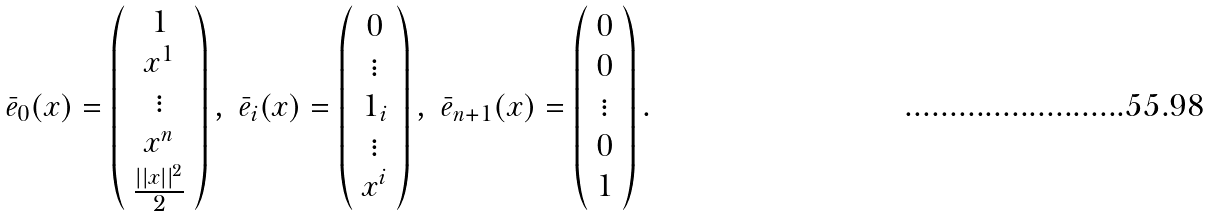<formula> <loc_0><loc_0><loc_500><loc_500>\bar { e } _ { 0 } ( x ) = \left ( \begin{array} { c } 1 \\ x ^ { 1 } \\ \vdots \\ x ^ { n } \\ \frac { | | x | | ^ { 2 } } { 2 } \end{array} \right ) , \ \bar { e } _ { i } ( x ) = \left ( \begin{array} { c } 0 \\ \vdots \\ 1 _ { i } \\ \vdots \\ x ^ { i } \end{array} \right ) , \ \bar { e } _ { n + 1 } ( x ) = \left ( \begin{array} { c } 0 \\ 0 \\ \vdots \\ 0 \\ 1 \end{array} \right ) .</formula> 